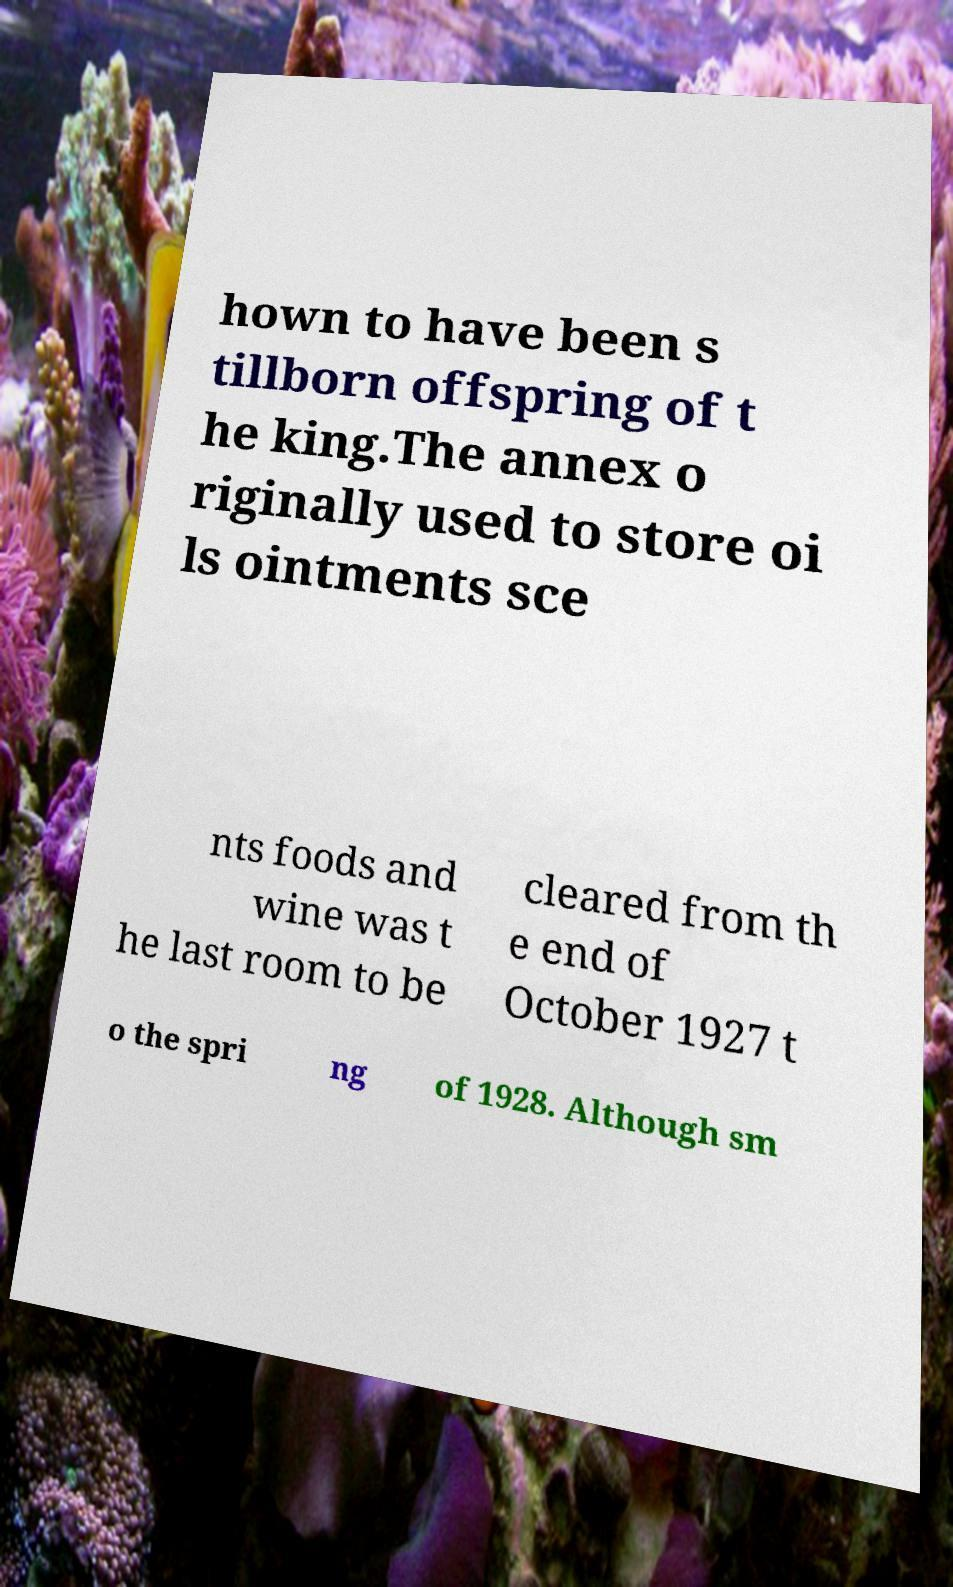Please read and relay the text visible in this image. What does it say? hown to have been s tillborn offspring of t he king.The annex o riginally used to store oi ls ointments sce nts foods and wine was t he last room to be cleared from th e end of October 1927 t o the spri ng of 1928. Although sm 